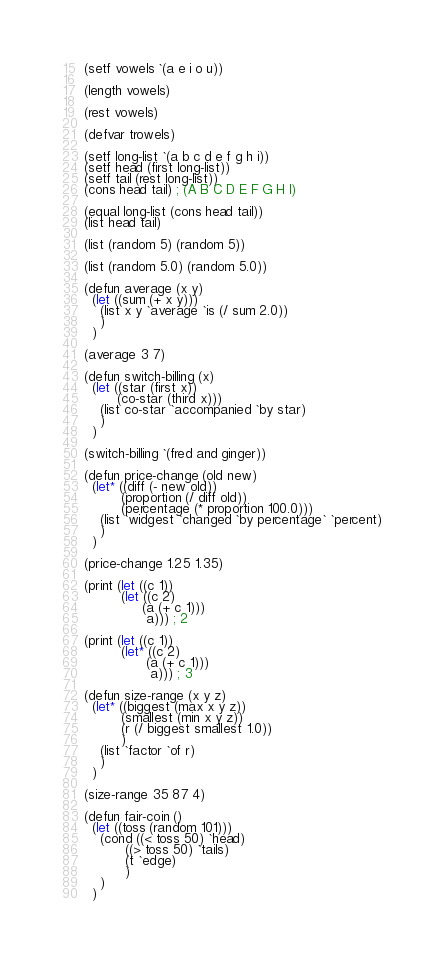Convert code to text. <code><loc_0><loc_0><loc_500><loc_500><_Lisp_>(setf vowels `(a e i o u))

(length vowels)

(rest vowels)

(defvar trowels)

(setf long-list `(a b c d e f g h i))
(setf head (first long-list))
(setf tail (rest long-list))
(cons head tail) ; (A B C D E F G H I)

(equal long-list (cons head tail))
(list head tail)

(list (random 5) (random 5))

(list (random 5.0) (random 5.0))

(defun average (x y)
  (let ((sum (+ x y)))
    (list x y `average `is (/ sum 2.0))
    )
  )

(average 3 7)

(defun switch-billing (x)
  (let ((star (first x))
        (co-star (third x)))
    (list co-star `accompanied `by star)
    )
  )

(switch-billing `(fred and ginger))

(defun price-change (old new)
  (let* ((diff (- new old))
         (proportion (/ diff old))
         (percentage (* proportion 100.0)))
    (list `widgest `changed `by percentage` `percent)
    )
  )

(price-change 1.25 1.35)

(print (let ((c 1))
         (let ((c 2)
              (a (+ c 1)))
               a))) ; 2

(print (let ((c 1))
         (let* ((c 2)
               (a (+ c 1)))
                a))) ; 3

(defun size-range (x y z)
  (let* ((biggest (max x y z))
         (smallest (min x y z))
         (r (/ biggest smallest 1.0))
         )
    (list `factor `of r)
    )
  )

(size-range 35 87 4)

(defun fair-coin ()
  (let ((toss (random 101)))
    (cond ((< toss 50) `head)
          ((> toss 50) `tails)
          (t `edge)
          )
    )
  )
</code> 